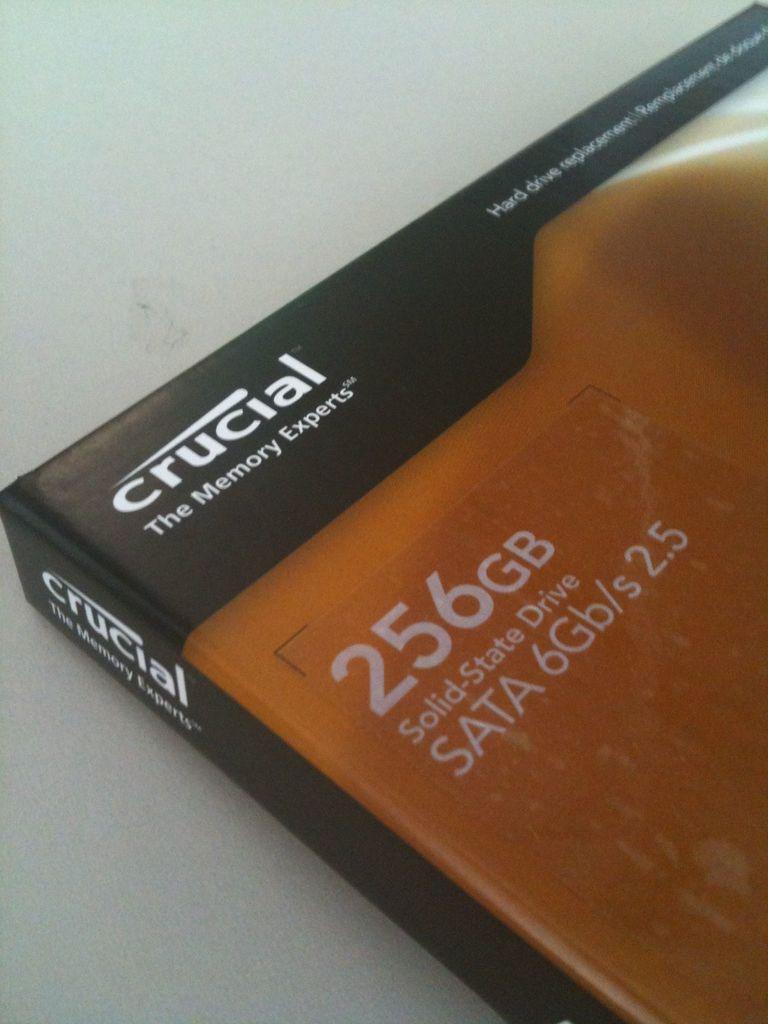How many gigabytes is the drive?
Provide a succinct answer. 256. Which  company made the solid state drive?
Provide a succinct answer. Crucial. 